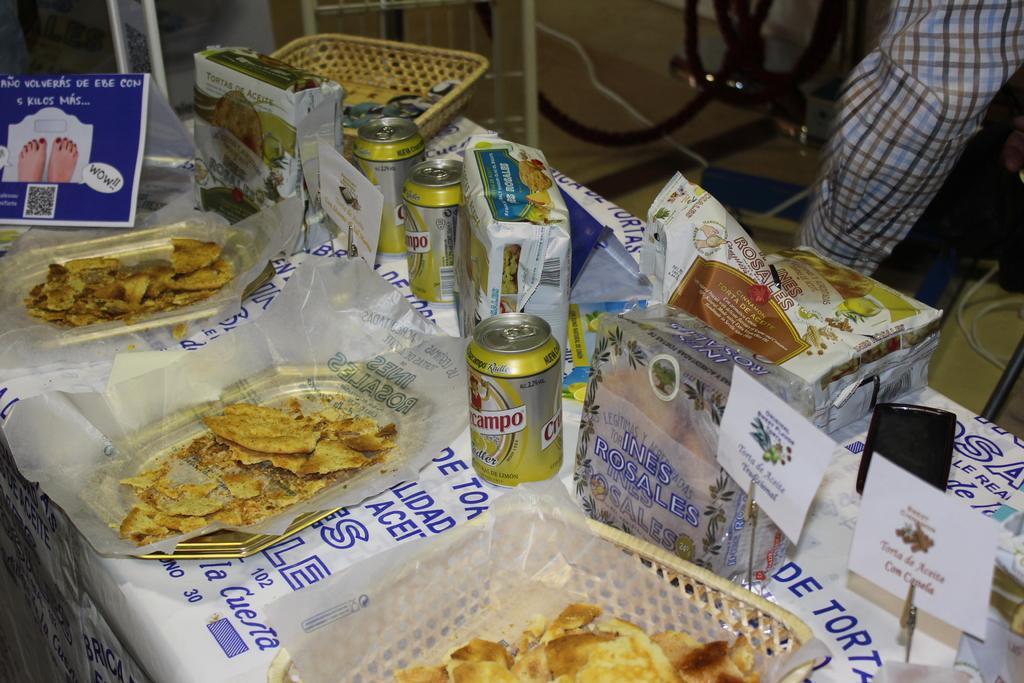Could you give a brief overview of what you see in this image? In this picture we can see tins, baskets, food items, papers, mobile and some objects. In the background we can see a cloth and cables on the floor. 